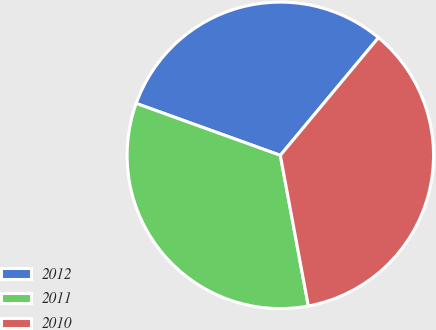Convert chart. <chart><loc_0><loc_0><loc_500><loc_500><pie_chart><fcel>2012<fcel>2011<fcel>2010<nl><fcel>30.56%<fcel>33.43%<fcel>36.01%<nl></chart> 